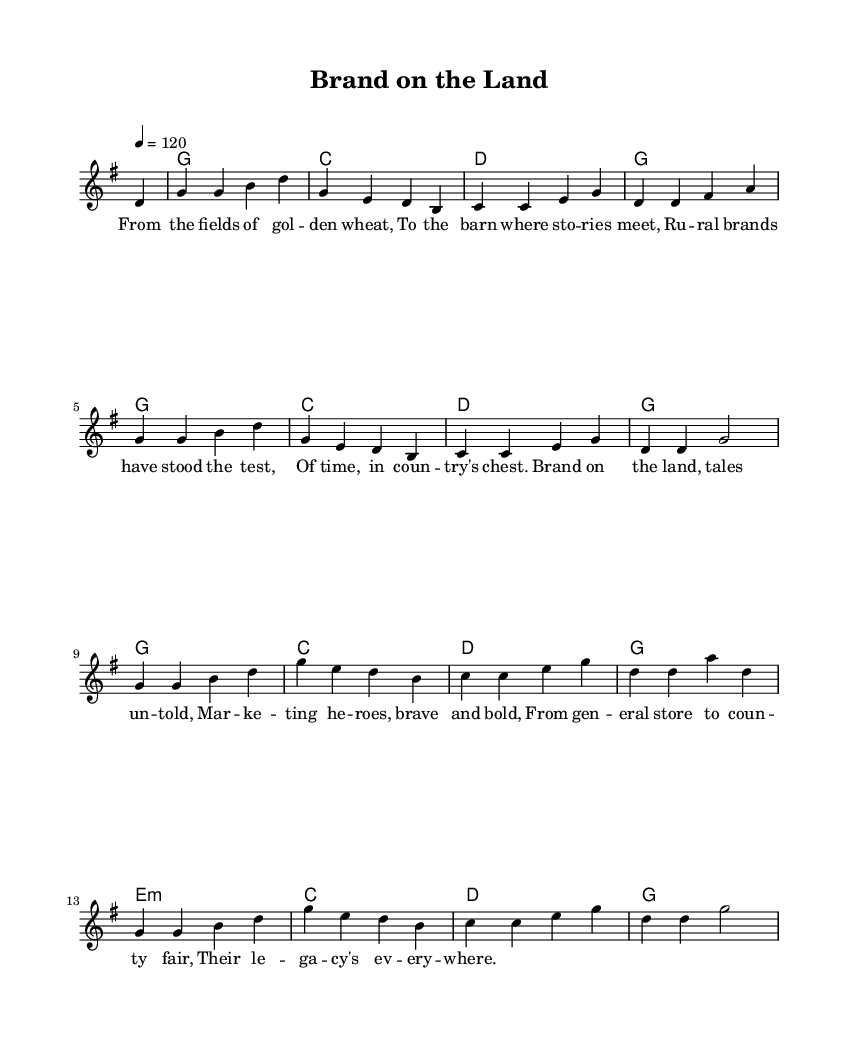What is the key signature of this music? The key signature included at the beginning of the score indicates G major, which has one sharp (F#).
Answer: G major What is the time signature of this music? The time signature at the beginning of the score shows 4/4, meaning there are four beats per measure and a quarter note receives one beat.
Answer: 4/4 What is the tempo marking for this piece? The tempo marking states that the piece is to be played at a speed of 120 beats per minute, indicated at the beginning of the score.
Answer: 120 How many measures are in the melody section? By counting the measures in the melody part, which starts after the initial partial measure, there are 16 measures in total.
Answer: 16 Which chords are predominantly used in the harmony? The harmony section includes chords G, C, D, and E minor, with G being the most frequently used chord throughout the piece.
Answer: G, C, D, E minor What theme do the lyrics explore? The lyrics discuss rural branding, emphasizing the stories and heritage tied to country life and marketing in rural areas.
Answer: Rural branding What is the overall structure of the song? The song structure consists of a repeated melody accompanied by a consistent chord progression, typical for bluegrass-infused country music.
Answer: Repeated melody and consistent chord progression 